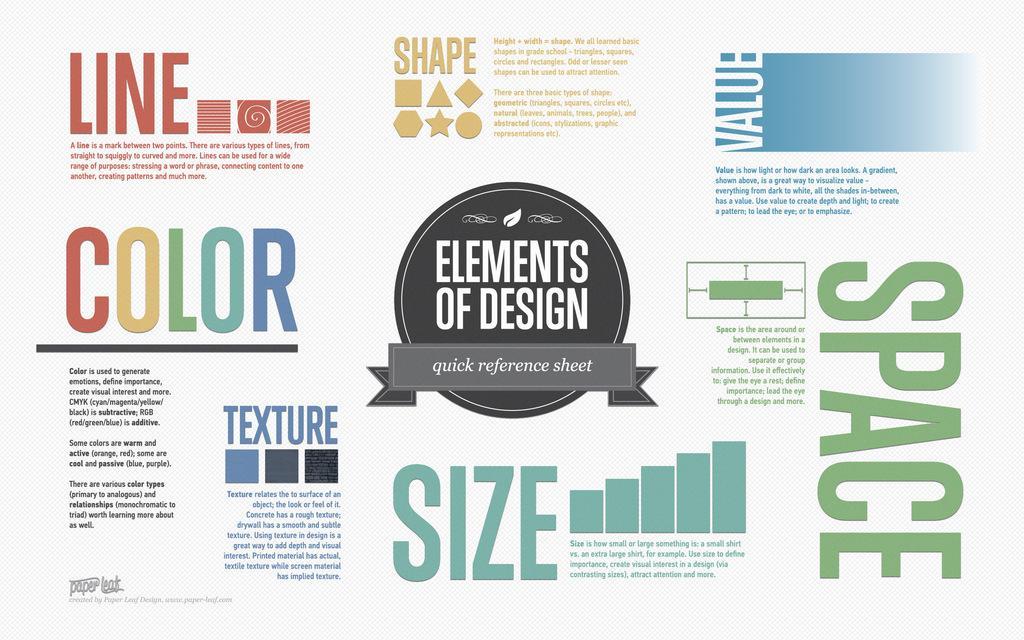Could you give a brief overview of what you see in this image? In this image we can see a poster with text, and symbols on it. 